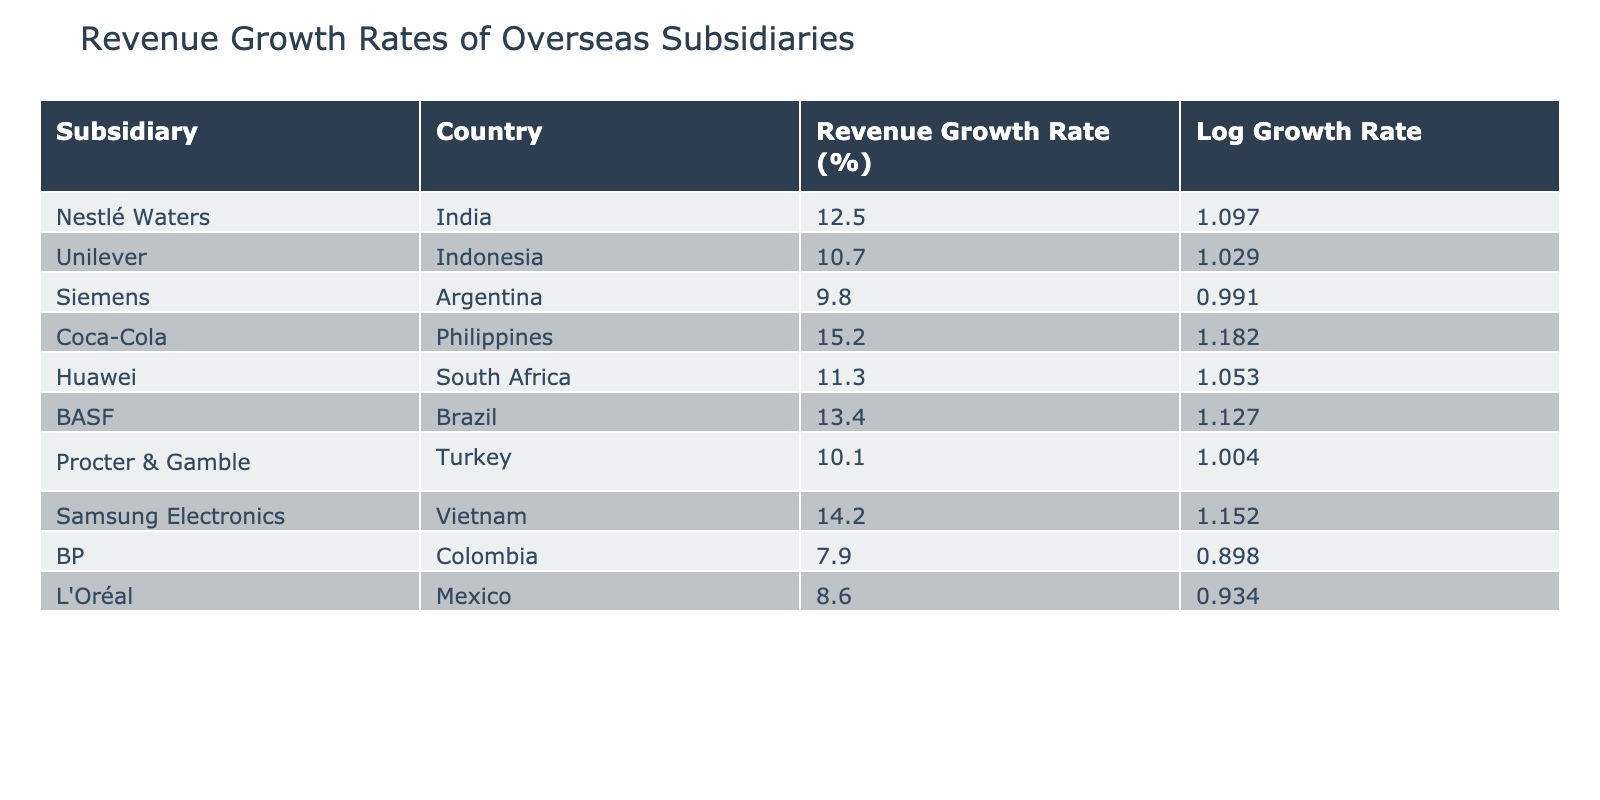What is the highest revenue growth rate among the subsidiaries? The table lists revenue growth rates for various subsidiaries. By scanning the 'Revenue Growth Rate (%)' column, Coca-Cola has the highest percentage at 15.2%.
Answer: 15.2% Which subsidiary has a revenue growth rate higher than 12%? By inspecting the table, Coca-Cola (15.2%), BASF (13.4%), and Samsung Electronics (14.2%) have growth rates above 12%.
Answer: Coca-Cola, BASF, Samsung Electronics What is the average revenue growth rate of all subsidiaries listed? To find the average, sum the growth rates: 12.5 + 10.7 + 9.8 + 15.2 + 11.3 + 13.4 + 10.1 + 14.2 + 7.9 + 8.6 =  10.72; then divide by the number 10 for the average: 10.72/10 = 10.72%.
Answer: 10.72% Is it true that Siemens has a higher growth rate than Huawei? From the table, Siemens has a growth rate of 9.8% and Huawei has a growth rate of 11.3%. Since 9.8% is less than 11.3%, the statement is false.
Answer: No Which country has the lowest revenue growth rate among the subsidiaries listed? By analyzing the 'Revenue Growth Rate (%)' column, the lowest rate is from BP in Colombia, with a growth rate of 7.9%.
Answer: Colombia What is the difference in revenue growth rates between Procter & Gamble and Unilever? The revenue growth rate for Procter & Gamble is 10.1% and for Unilever is 10.7%. The difference is calculated as 10.7% - 10.1% = 0.6%.
Answer: 0.6% Are there more subsidiaries with growth rates below 10% than those above? The table shows 3 subsidiaries (Siemens, BP, and L'Oréal) with rates below 10%. There are 7 subsidiaries with rates above 10%. Therefore, the statement is false since 7 is greater than 3.
Answer: No What is the combined revenue growth rate of BASF and Huawei? Adding the revenue growth rates of BASF (13.4%) and Huawei (11.3%) gives us 13.4 + 11.3 = 24.7%.
Answer: 24.7% Which subsidiary has the lowest logarithmic growth rate? To find this, the logarithmic growth rates must be calculated first: BP has the lowest revenue growth rate of 7.9%, thus its log growth rate will also be the lowest among the others.
Answer: BP 